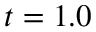<formula> <loc_0><loc_0><loc_500><loc_500>t = 1 . 0</formula> 